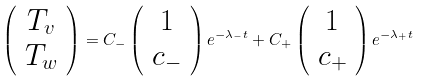Convert formula to latex. <formula><loc_0><loc_0><loc_500><loc_500>\left ( \begin{array} { c } T _ { v } \\ T _ { w } \\ \end{array} \right ) = C _ { - } \left ( \begin{array} { c } 1 \\ c _ { - } \\ \end{array} \right ) e ^ { - \lambda _ { - } t } + C _ { + } \left ( \begin{array} { c } 1 \\ c _ { + } \\ \end{array} \right ) e ^ { - \lambda _ { + } t }</formula> 